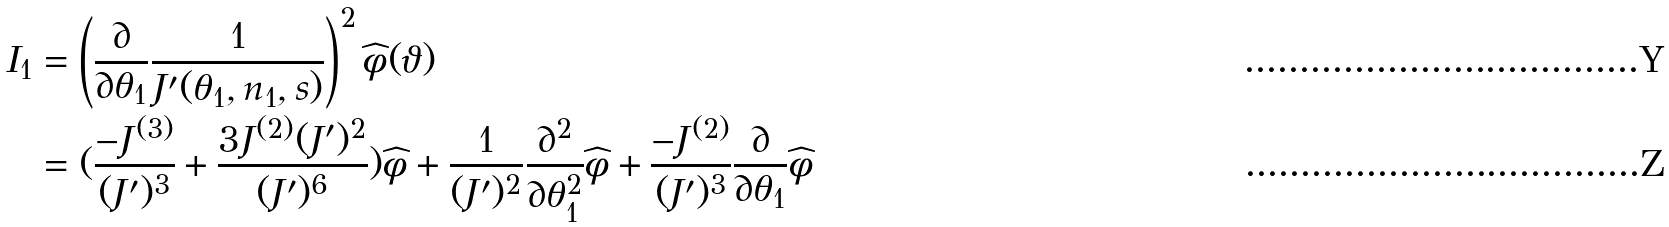<formula> <loc_0><loc_0><loc_500><loc_500>I _ { 1 } & = \left ( \frac { \partial } { \partial \theta _ { 1 } } \frac { 1 } { J ^ { \prime } ( \theta _ { 1 } , n _ { 1 } , s ) } \right ) ^ { 2 } \widehat { \phi } ( \vartheta ) \\ & = ( \frac { - J ^ { ( 3 ) } } { ( J ^ { \prime } ) ^ { 3 } } + \frac { 3 J ^ { ( 2 ) } ( J ^ { \prime } ) ^ { 2 } } { ( J ^ { \prime } ) ^ { 6 } } ) \widehat { \phi } + \frac { 1 } { ( J ^ { \prime } ) ^ { 2 } } \frac { \partial ^ { 2 } } { \partial \theta _ { 1 } ^ { 2 } } \widehat { \phi } + \frac { - J ^ { ( 2 ) } } { ( J ^ { \prime } ) ^ { 3 } } \frac { \partial } { \partial \theta _ { 1 } } \widehat { \phi }</formula> 